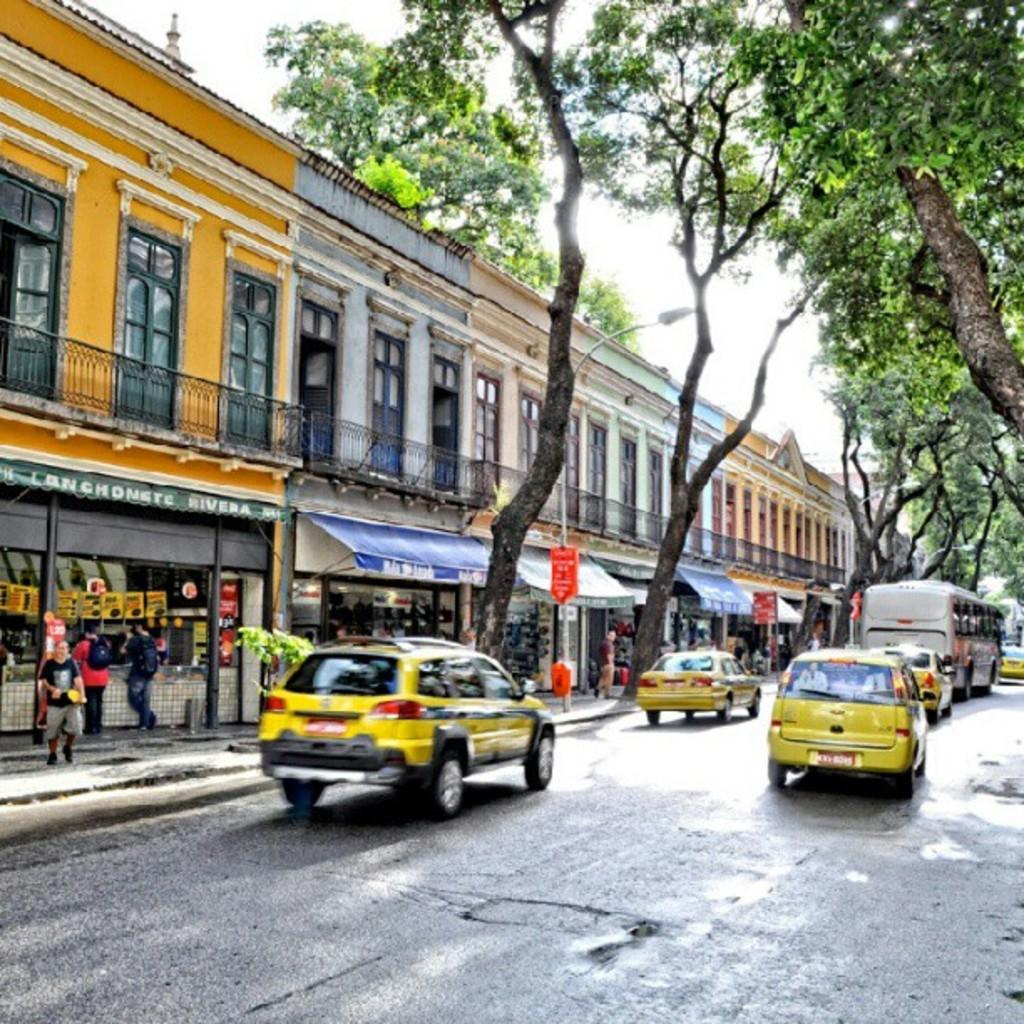<image>
Create a compact narrative representing the image presented. The green store to the left is called Rivera. 